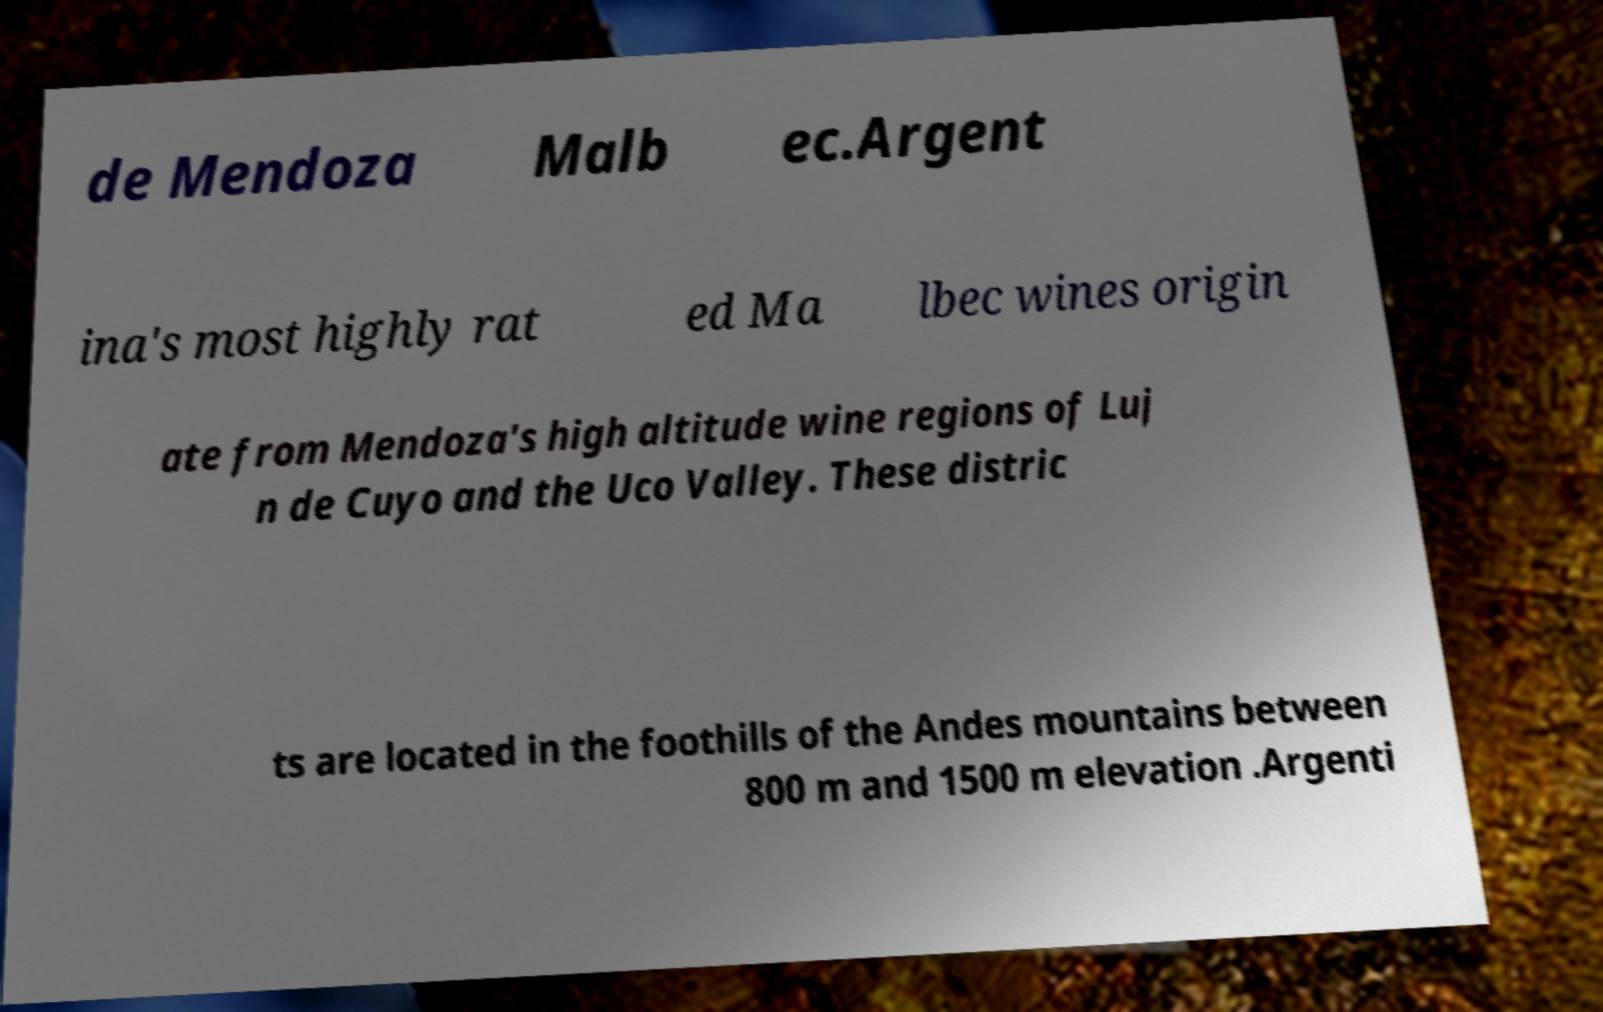What messages or text are displayed in this image? I need them in a readable, typed format. de Mendoza Malb ec.Argent ina's most highly rat ed Ma lbec wines origin ate from Mendoza's high altitude wine regions of Luj n de Cuyo and the Uco Valley. These distric ts are located in the foothills of the Andes mountains between 800 m and 1500 m elevation .Argenti 